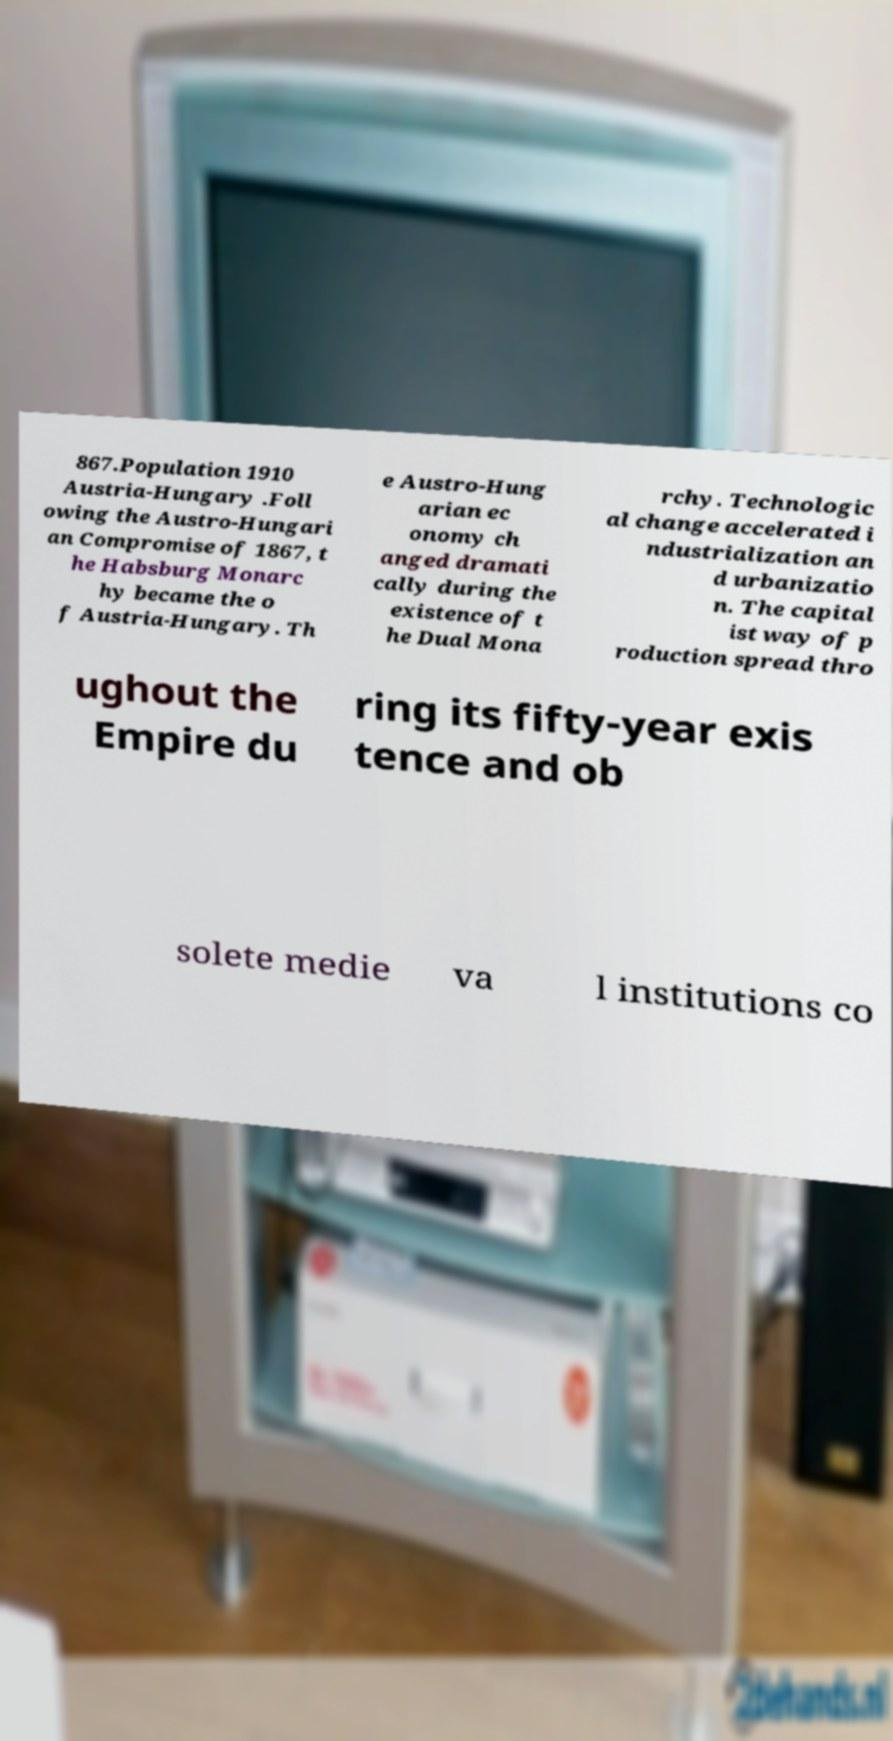What messages or text are displayed in this image? I need them in a readable, typed format. 867.Population 1910 Austria-Hungary .Foll owing the Austro-Hungari an Compromise of 1867, t he Habsburg Monarc hy became the o f Austria-Hungary. Th e Austro-Hung arian ec onomy ch anged dramati cally during the existence of t he Dual Mona rchy. Technologic al change accelerated i ndustrialization an d urbanizatio n. The capital ist way of p roduction spread thro ughout the Empire du ring its fifty-year exis tence and ob solete medie va l institutions co 